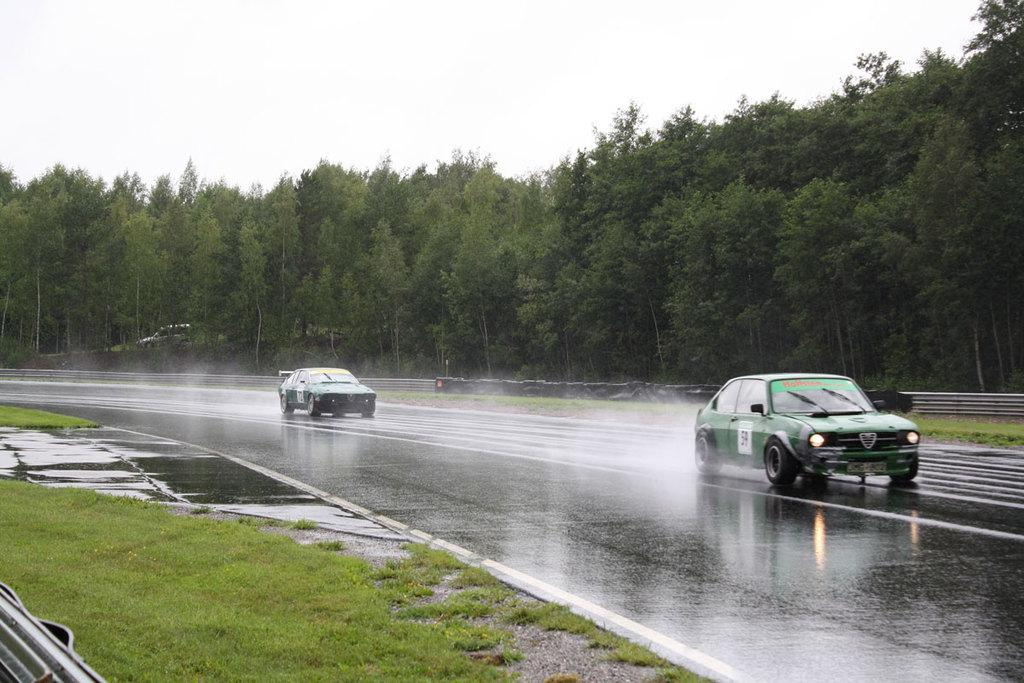What is the main feature of the image? There is a road in the image. How many cars are on the road? There are 2 cars on the road. What type of vegetation is present on the ground? There is grass on the ground. What is the condition of the road in the image? There is water on the road. What type of structure is present in the image? There is a railing in the image. What can be seen in the background of the image? There are trees, a car, and the sky visible in the background. What type of fact can be heard being recited by the voice in the image? There is no voice or fact present in the image; it is a scene of a road with cars, grass, water, a railing, and background elements. 